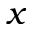<formula> <loc_0><loc_0><loc_500><loc_500>x</formula> 